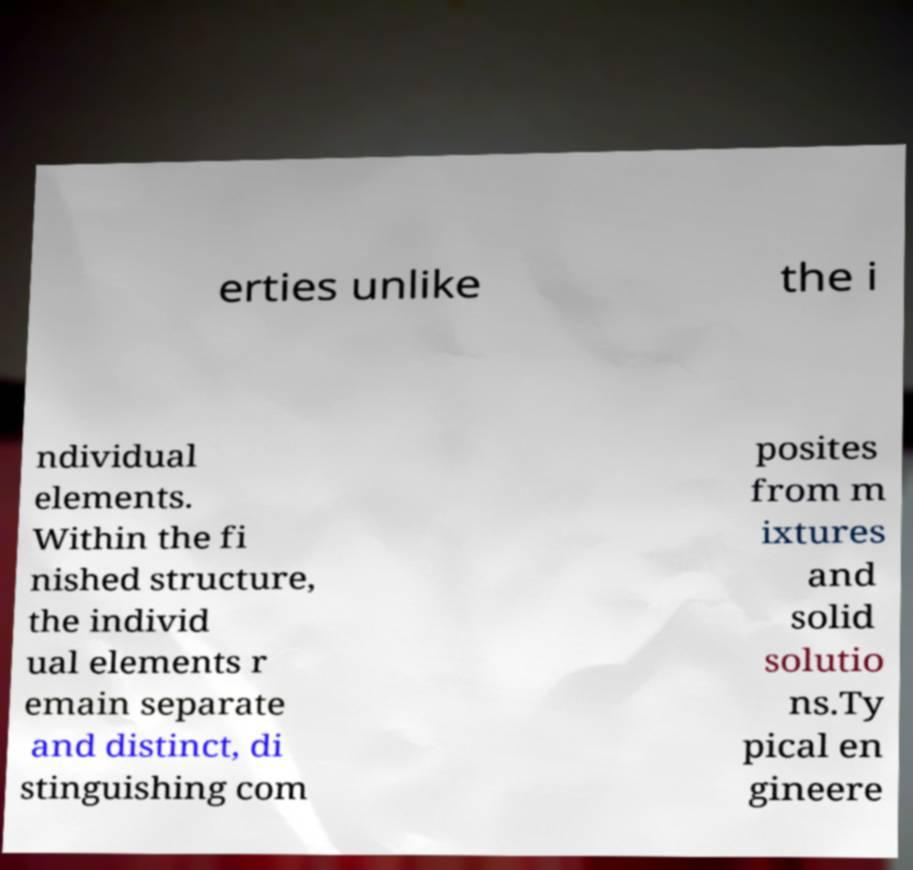Please read and relay the text visible in this image. What does it say? erties unlike the i ndividual elements. Within the fi nished structure, the individ ual elements r emain separate and distinct, di stinguishing com posites from m ixtures and solid solutio ns.Ty pical en gineere 